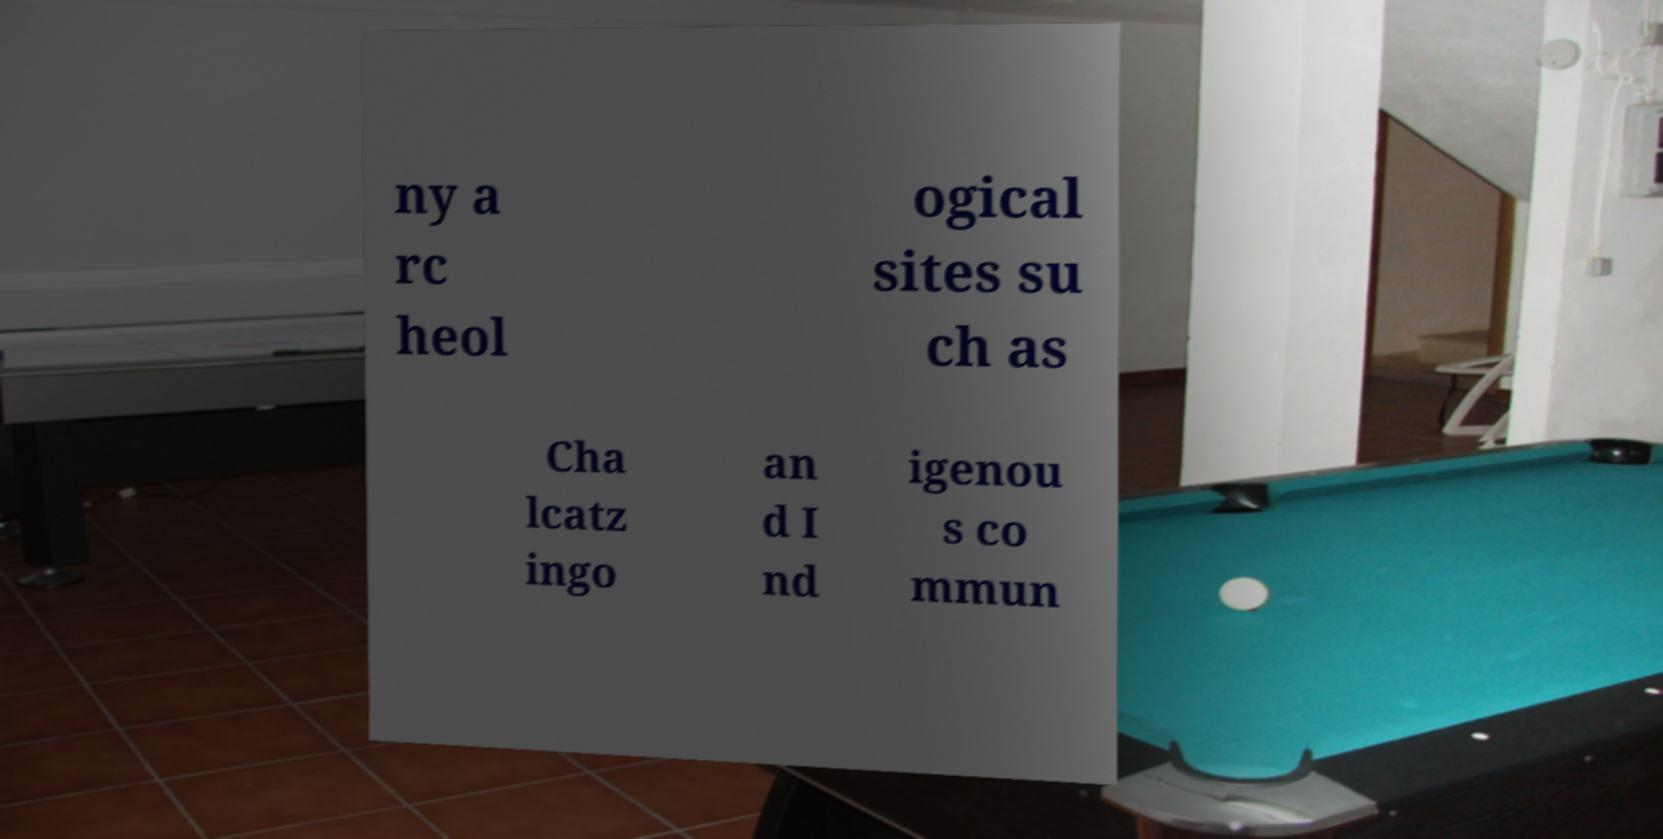Could you assist in decoding the text presented in this image and type it out clearly? ny a rc heol ogical sites su ch as Cha lcatz ingo an d I nd igenou s co mmun 